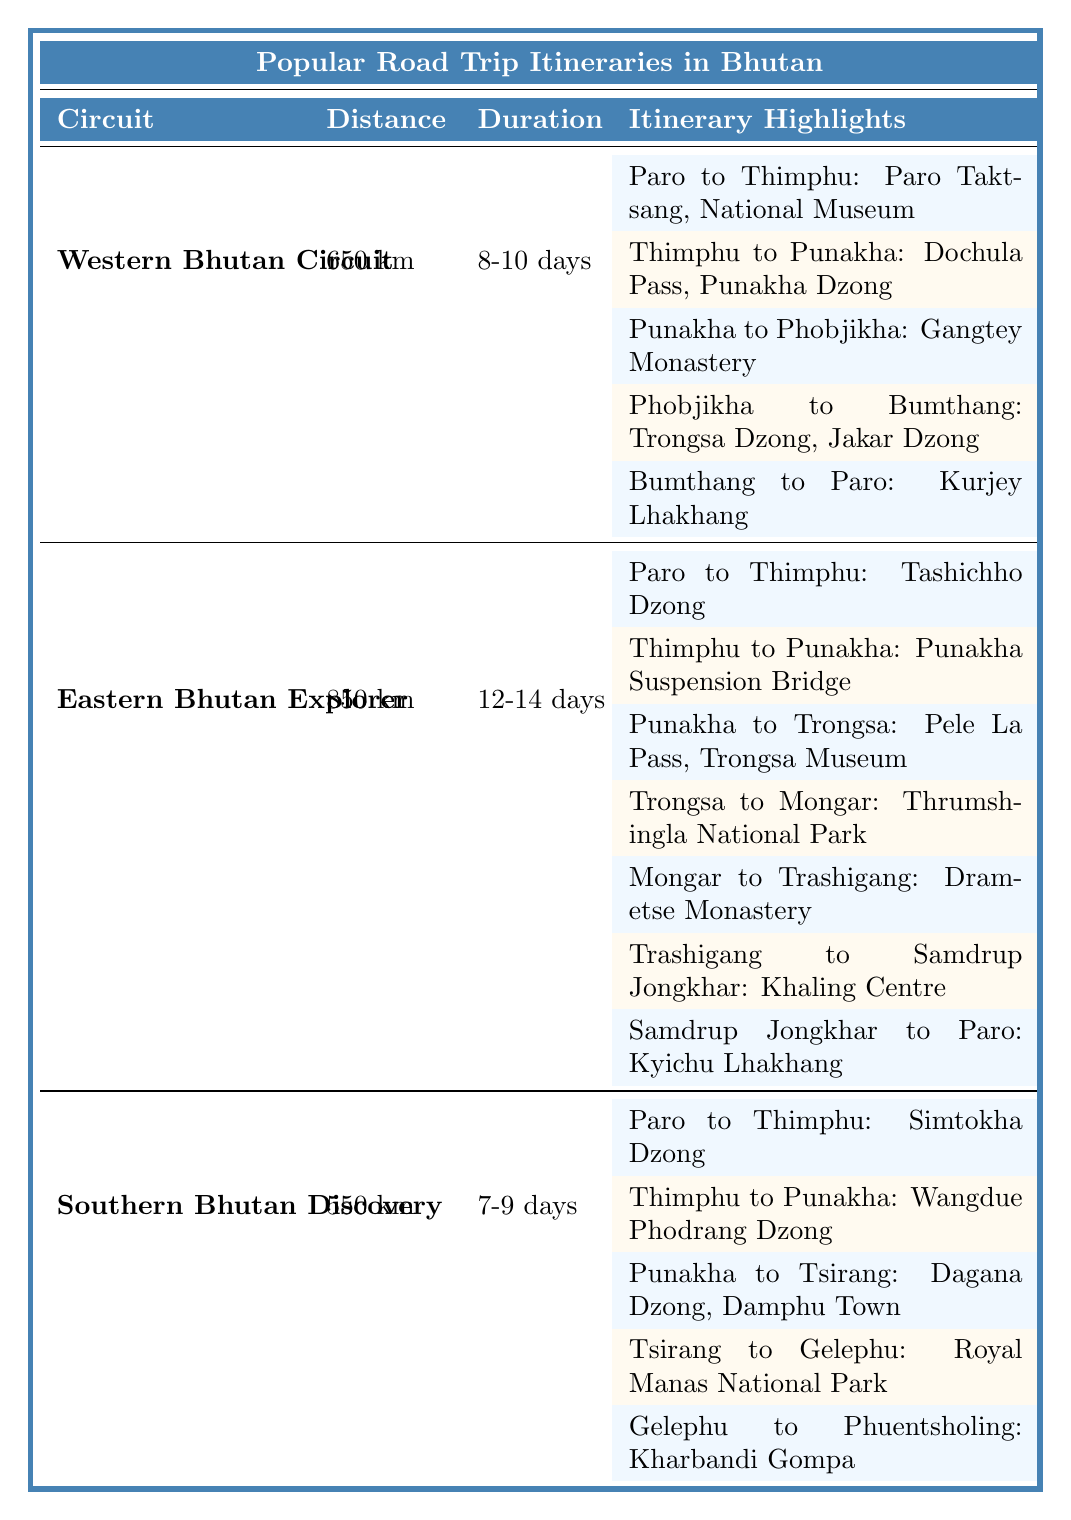What is the total distance for the Western Bhutan Circuit? The Western Bhutan Circuit's total distance is listed directly in the table under the "Total Distance" column, which shows "650 km."
Answer: 650 km How long does the Eastern Bhutan Explorer take to complete? The total duration for the Eastern Bhutan Explorer is provided in the table under the "Total Duration" column, which indicates "12-14 days."
Answer: 12-14 days Which itinerary highlights can be experienced while traveling from Punakha to Tsirang in the Southern Bhutan Discovery circuit? The table specifies the highlights for the leg from Punakha to Tsirang, which include "Dagana Dzong" and "Damphu Town."
Answer: Dagana Dzong, Damphu Town What is the total distance for all itineraries in Bhutan? To find the total distance, I will add the distances of all circuits: 650 km (Western) + 850 km (Eastern) + 550 km (Southern) = 2050 km.
Answer: 2050 km Is the distance from Thimphu to Punakha the same in all circuits? In the table, Thimphu to Punakha shows "75 km" for both the Western Bhutan Circuit and the Eastern Bhutan Explorer, confirming it is the same.
Answer: Yes In the Southern Bhutan Discovery, how many days are allocated for the trip from Tsirang to Gelephu? The itinerary states that the trip from Tsirang to Gelephu takes "1-2 days," as mentioned in the table.
Answer: 1-2 days Which circuit requires the longest travel time? By comparing the total durations for each circuit: Western Bhutan (8-10 days), Eastern Bhutan (12-14 days), Southern Bhutan (7-9 days), the Eastern Bhutan Explorer has the longest travel time.
Answer: Eastern Bhutan Explorer How many highlights are there when traveling from Mongar to Trashigang in the Eastern Bhutan Explorer? The leg from Mongar to Trashigang includes "Drametse Monastery" and "Trashigang Dzong," totaling 2 highlights.
Answer: 2 highlights What is the total distance covered when traveling from Bumthang to Paro in the Western Bhutan Circuit? From the itinerary, Bumthang to Paro covers a distance of "165 km" as indicated in the table.
Answer: 165 km Which itinerary includes the Punakha Suspension Bridge as a highlight? The Eastern Bhutan Explorer itinerary lists the Punakha Suspension Bridge as a highlight during the trip from Thimphu to Punakha.
Answer: Eastern Bhutan Explorer 